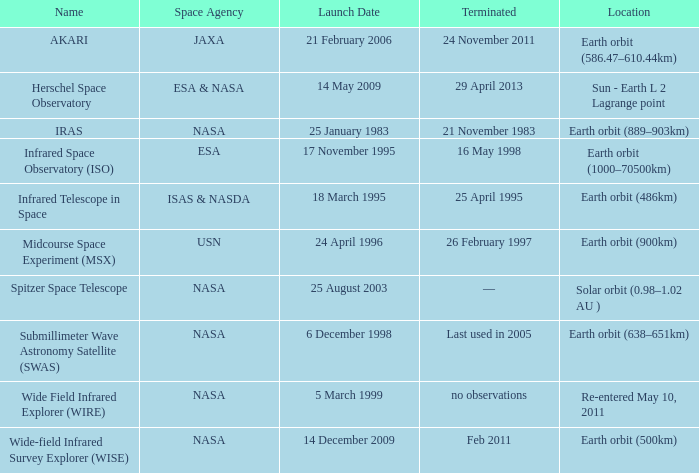When did NASA launch the wide field infrared explorer (wire)? 5 March 1999. 